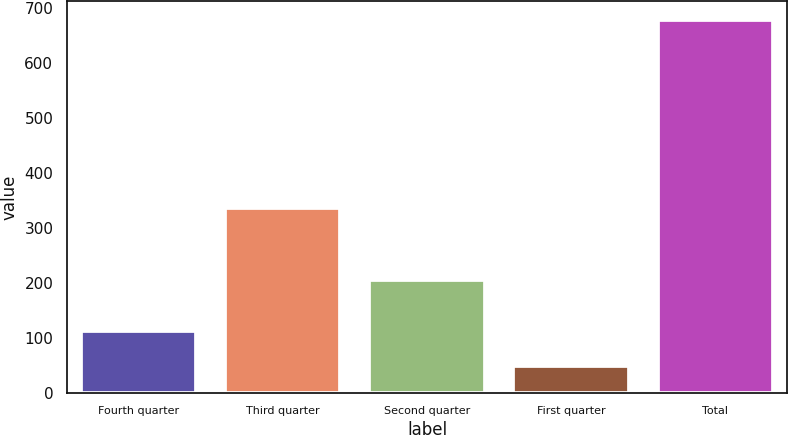Convert chart to OTSL. <chart><loc_0><loc_0><loc_500><loc_500><bar_chart><fcel>Fourth quarter<fcel>Third quarter<fcel>Second quarter<fcel>First quarter<fcel>Total<nl><fcel>112<fcel>337<fcel>205<fcel>49<fcel>679<nl></chart> 